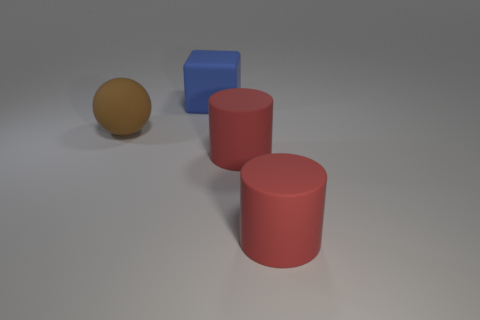Are there fewer big blue blocks to the left of the large blue matte cube than big blue shiny things?
Ensure brevity in your answer.  No. What is the shape of the blue thing that is the same size as the brown rubber ball?
Make the answer very short. Cube. How many other objects are the same color as the large matte block?
Ensure brevity in your answer.  0. Is the size of the blue thing the same as the brown rubber ball?
Provide a short and direct response. Yes. How many things are small metal balls or matte objects right of the large blue thing?
Give a very brief answer. 2. Are there fewer cubes in front of the big blue matte thing than matte cylinders that are right of the brown rubber object?
Ensure brevity in your answer.  Yes. What number of other objects are there of the same material as the brown ball?
Make the answer very short. 3. There is a matte object that is left of the big matte cube; is there a big blue rubber object behind it?
Offer a very short reply. Yes. The large blue thing that is made of the same material as the brown sphere is what shape?
Offer a terse response. Cube. Are there any other things that are the same shape as the blue object?
Provide a succinct answer. No. 